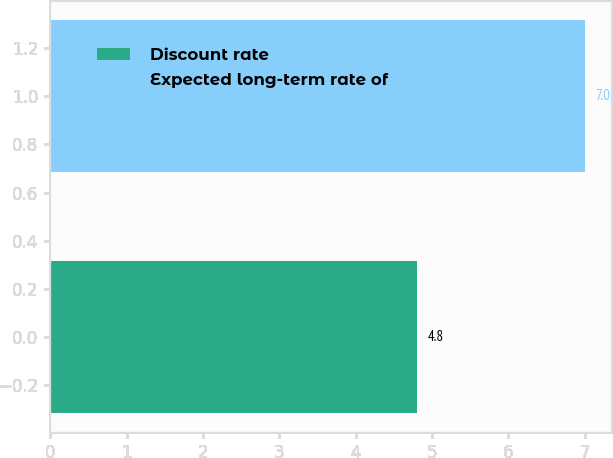Convert chart to OTSL. <chart><loc_0><loc_0><loc_500><loc_500><bar_chart><fcel>Discount rate<fcel>Expected long-term rate of<nl><fcel>4.8<fcel>7<nl></chart> 